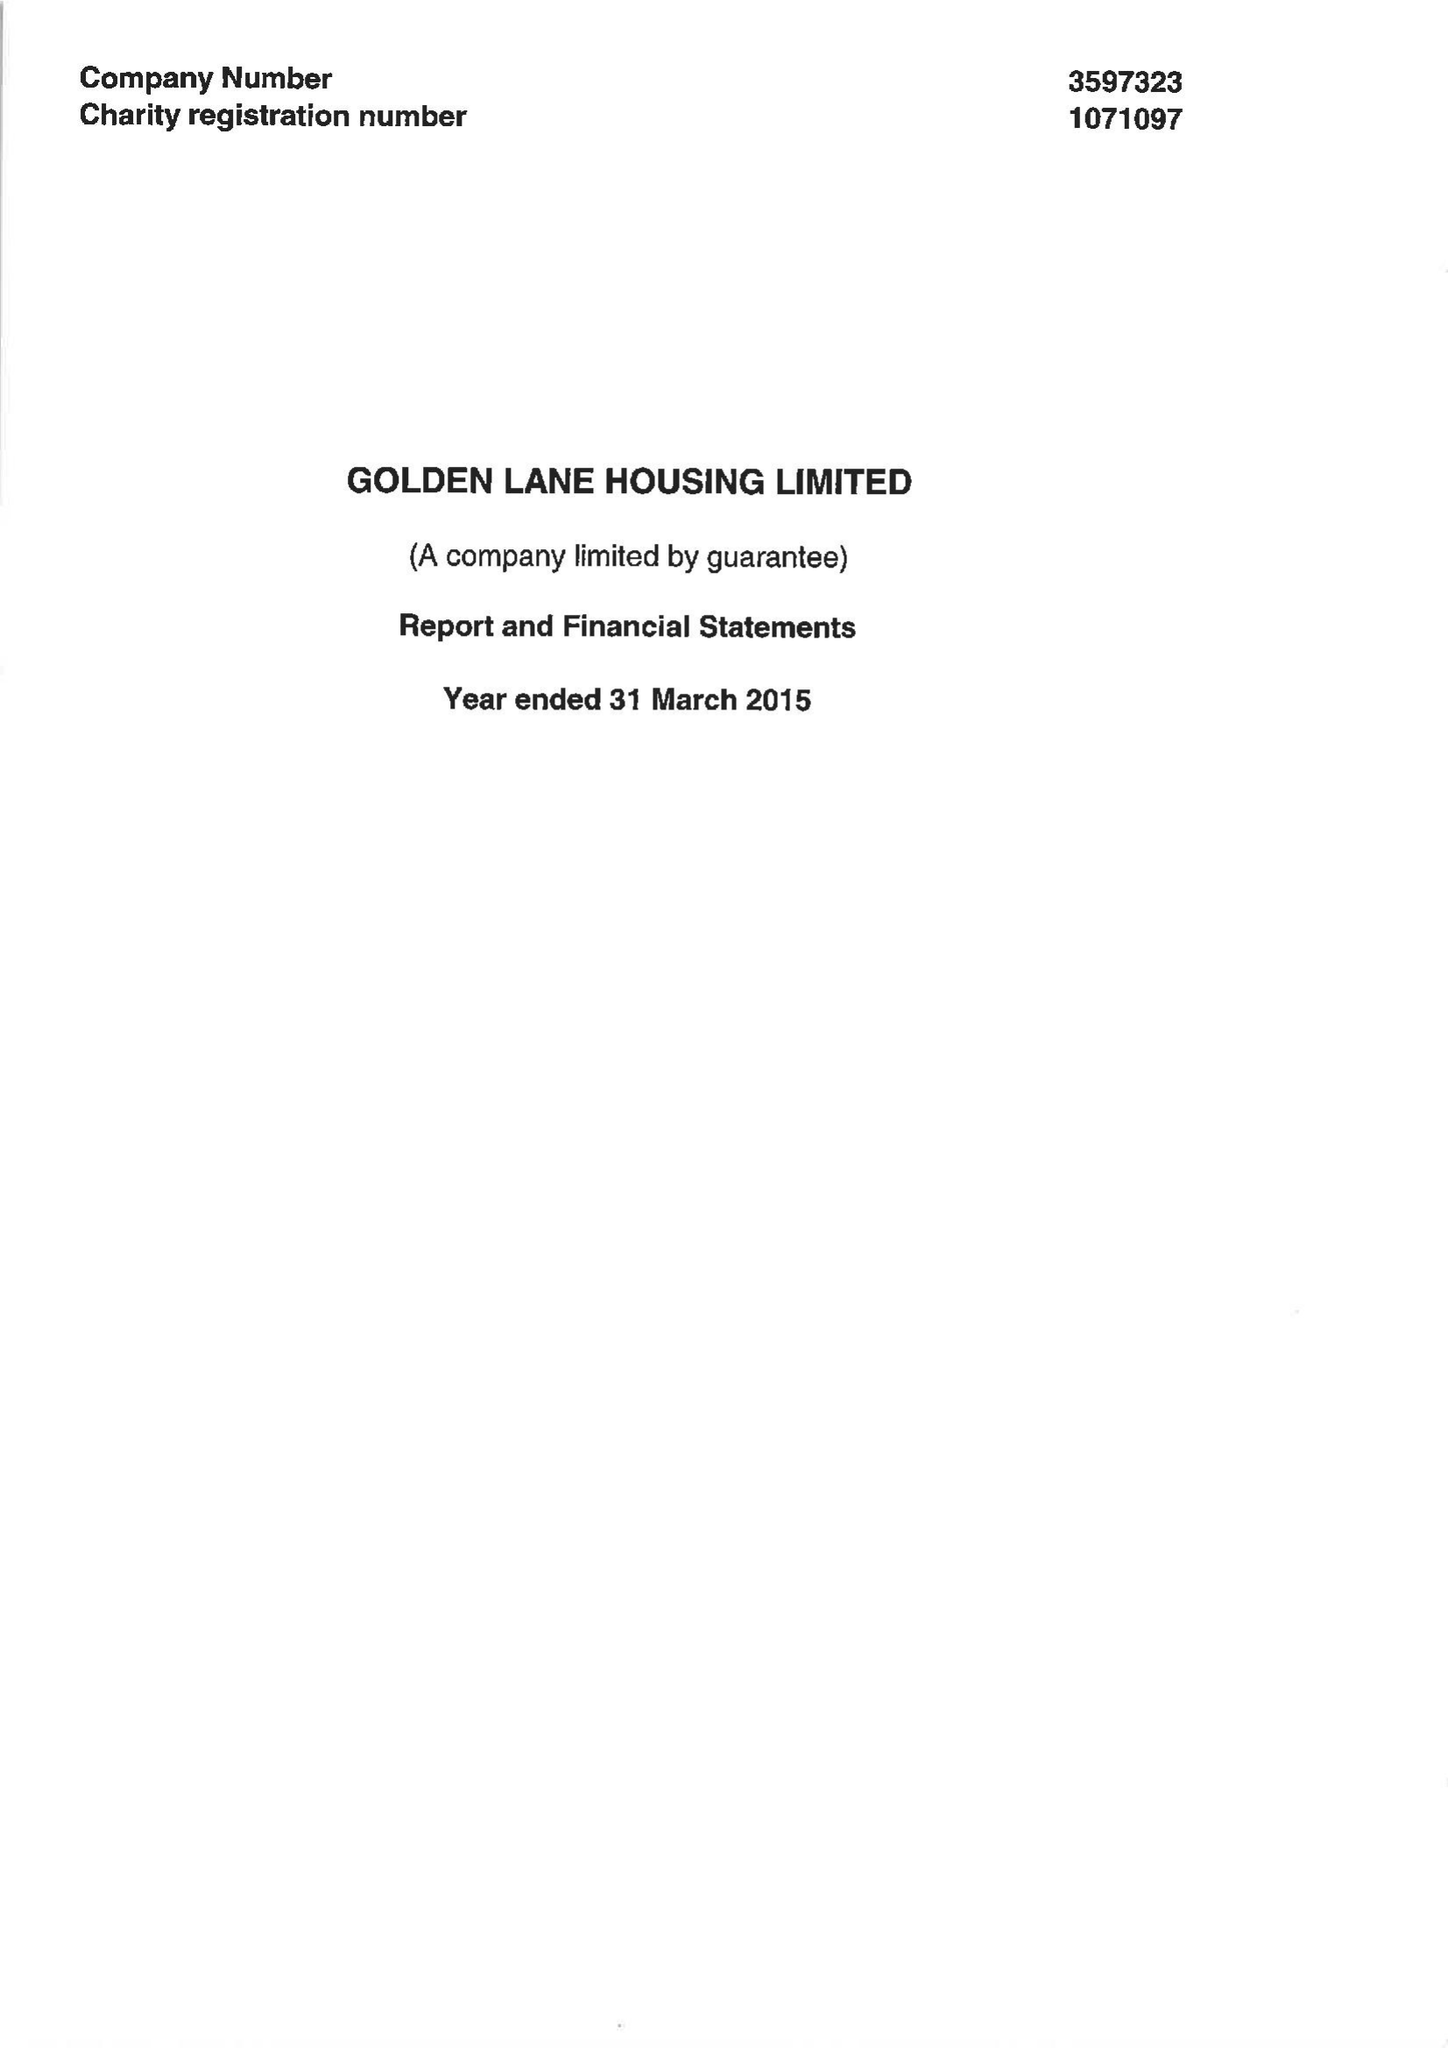What is the value for the charity_name?
Answer the question using a single word or phrase. Golden Lane Housing Ltd. 